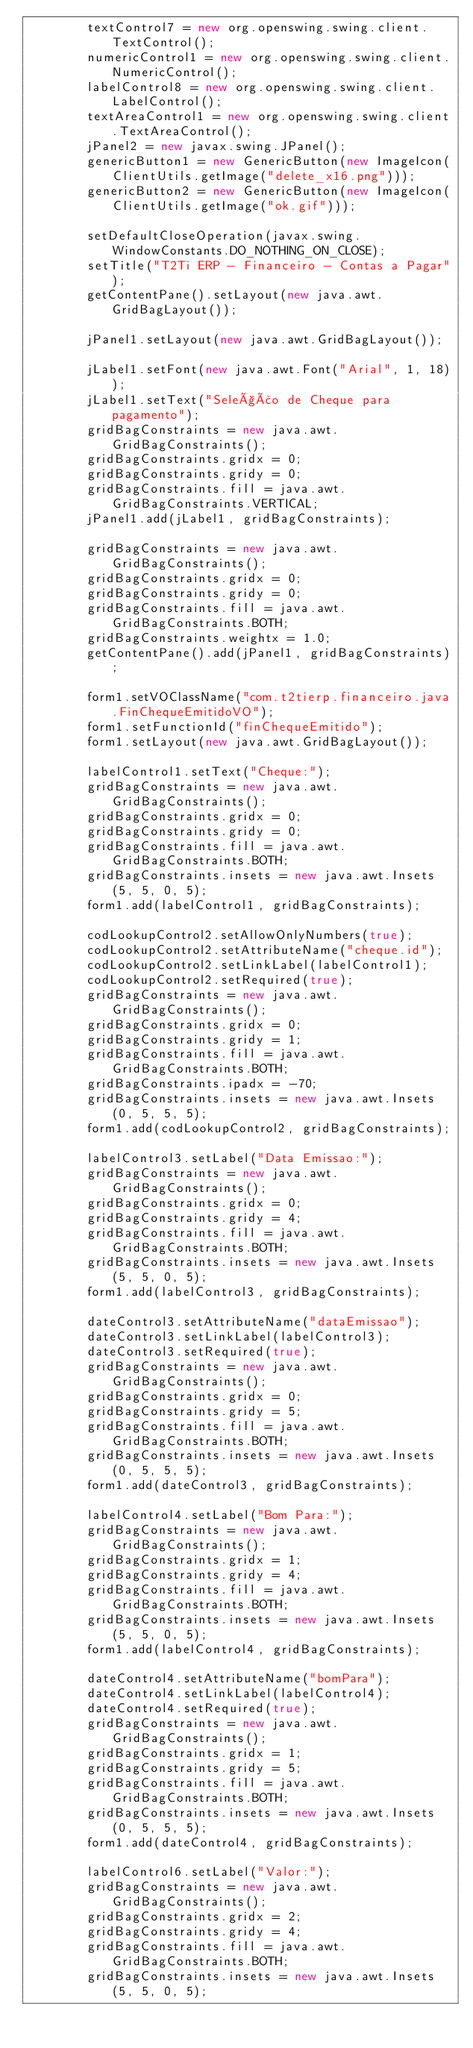Convert code to text. <code><loc_0><loc_0><loc_500><loc_500><_Java_>        textControl7 = new org.openswing.swing.client.TextControl();
        numericControl1 = new org.openswing.swing.client.NumericControl();
        labelControl8 = new org.openswing.swing.client.LabelControl();
        textAreaControl1 = new org.openswing.swing.client.TextAreaControl();
        jPanel2 = new javax.swing.JPanel();
        genericButton1 = new GenericButton(new ImageIcon(ClientUtils.getImage("delete_x16.png")));
        genericButton2 = new GenericButton(new ImageIcon(ClientUtils.getImage("ok.gif")));

        setDefaultCloseOperation(javax.swing.WindowConstants.DO_NOTHING_ON_CLOSE);
        setTitle("T2Ti ERP - Financeiro - Contas a Pagar");
        getContentPane().setLayout(new java.awt.GridBagLayout());

        jPanel1.setLayout(new java.awt.GridBagLayout());

        jLabel1.setFont(new java.awt.Font("Arial", 1, 18));
        jLabel1.setText("Seleção de Cheque para pagamento");
        gridBagConstraints = new java.awt.GridBagConstraints();
        gridBagConstraints.gridx = 0;
        gridBagConstraints.gridy = 0;
        gridBagConstraints.fill = java.awt.GridBagConstraints.VERTICAL;
        jPanel1.add(jLabel1, gridBagConstraints);

        gridBagConstraints = new java.awt.GridBagConstraints();
        gridBagConstraints.gridx = 0;
        gridBagConstraints.gridy = 0;
        gridBagConstraints.fill = java.awt.GridBagConstraints.BOTH;
        gridBagConstraints.weightx = 1.0;
        getContentPane().add(jPanel1, gridBagConstraints);

        form1.setVOClassName("com.t2tierp.financeiro.java.FinChequeEmitidoVO");
        form1.setFunctionId("finChequeEmitido");
        form1.setLayout(new java.awt.GridBagLayout());

        labelControl1.setText("Cheque:");
        gridBagConstraints = new java.awt.GridBagConstraints();
        gridBagConstraints.gridx = 0;
        gridBagConstraints.gridy = 0;
        gridBagConstraints.fill = java.awt.GridBagConstraints.BOTH;
        gridBagConstraints.insets = new java.awt.Insets(5, 5, 0, 5);
        form1.add(labelControl1, gridBagConstraints);

        codLookupControl2.setAllowOnlyNumbers(true);
        codLookupControl2.setAttributeName("cheque.id");
        codLookupControl2.setLinkLabel(labelControl1);
        codLookupControl2.setRequired(true);
        gridBagConstraints = new java.awt.GridBagConstraints();
        gridBagConstraints.gridx = 0;
        gridBagConstraints.gridy = 1;
        gridBagConstraints.fill = java.awt.GridBagConstraints.BOTH;
        gridBagConstraints.ipadx = -70;
        gridBagConstraints.insets = new java.awt.Insets(0, 5, 5, 5);
        form1.add(codLookupControl2, gridBagConstraints);

        labelControl3.setLabel("Data Emissao:");
        gridBagConstraints = new java.awt.GridBagConstraints();
        gridBagConstraints.gridx = 0;
        gridBagConstraints.gridy = 4;
        gridBagConstraints.fill = java.awt.GridBagConstraints.BOTH;
        gridBagConstraints.insets = new java.awt.Insets(5, 5, 0, 5);
        form1.add(labelControl3, gridBagConstraints);

        dateControl3.setAttributeName("dataEmissao");
        dateControl3.setLinkLabel(labelControl3);
        dateControl3.setRequired(true);
        gridBagConstraints = new java.awt.GridBagConstraints();
        gridBagConstraints.gridx = 0;
        gridBagConstraints.gridy = 5;
        gridBagConstraints.fill = java.awt.GridBagConstraints.BOTH;
        gridBagConstraints.insets = new java.awt.Insets(0, 5, 5, 5);
        form1.add(dateControl3, gridBagConstraints);

        labelControl4.setLabel("Bom Para:");
        gridBagConstraints = new java.awt.GridBagConstraints();
        gridBagConstraints.gridx = 1;
        gridBagConstraints.gridy = 4;
        gridBagConstraints.fill = java.awt.GridBagConstraints.BOTH;
        gridBagConstraints.insets = new java.awt.Insets(5, 5, 0, 5);
        form1.add(labelControl4, gridBagConstraints);

        dateControl4.setAttributeName("bomPara");
        dateControl4.setLinkLabel(labelControl4);
        dateControl4.setRequired(true);
        gridBagConstraints = new java.awt.GridBagConstraints();
        gridBagConstraints.gridx = 1;
        gridBagConstraints.gridy = 5;
        gridBagConstraints.fill = java.awt.GridBagConstraints.BOTH;
        gridBagConstraints.insets = new java.awt.Insets(0, 5, 5, 5);
        form1.add(dateControl4, gridBagConstraints);

        labelControl6.setLabel("Valor:");
        gridBagConstraints = new java.awt.GridBagConstraints();
        gridBagConstraints.gridx = 2;
        gridBagConstraints.gridy = 4;
        gridBagConstraints.fill = java.awt.GridBagConstraints.BOTH;
        gridBagConstraints.insets = new java.awt.Insets(5, 5, 0, 5);</code> 